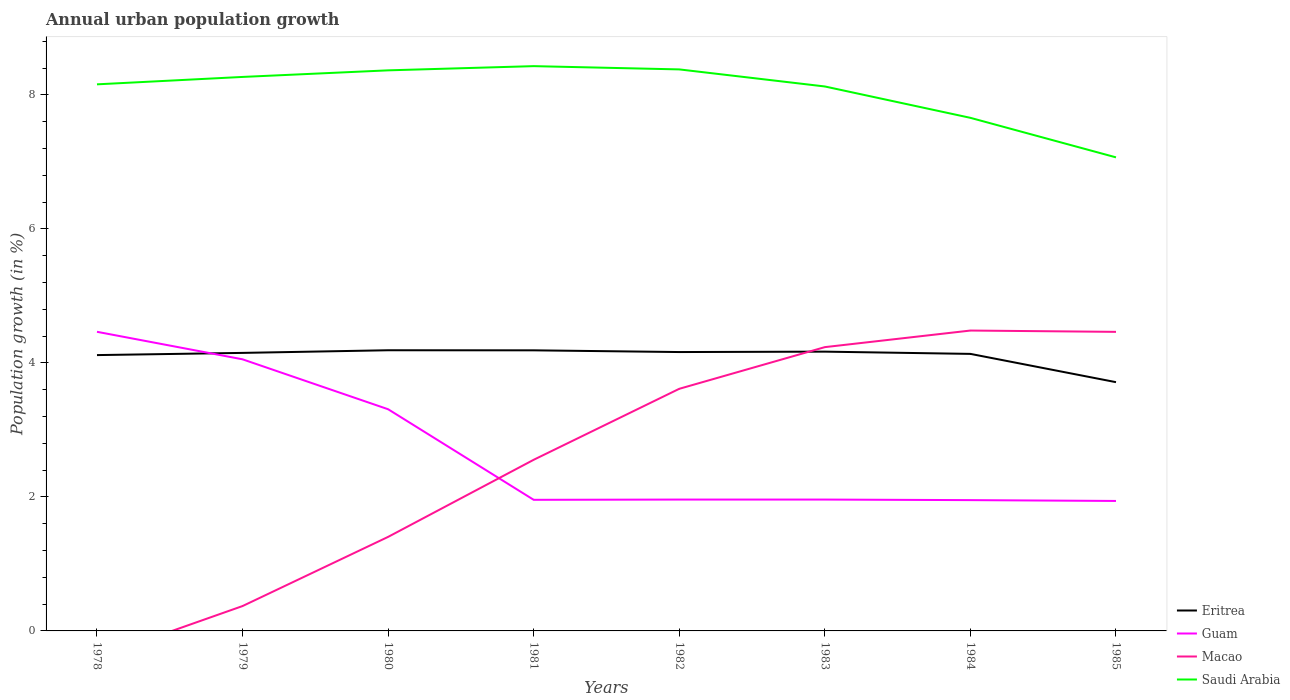Across all years, what is the maximum percentage of urban population growth in Eritrea?
Your answer should be compact. 3.71. What is the total percentage of urban population growth in Macao in the graph?
Your response must be concise. -0.87. What is the difference between the highest and the second highest percentage of urban population growth in Saudi Arabia?
Your response must be concise. 1.36. What is the difference between the highest and the lowest percentage of urban population growth in Guam?
Provide a short and direct response. 3. Is the percentage of urban population growth in Guam strictly greater than the percentage of urban population growth in Saudi Arabia over the years?
Make the answer very short. Yes. How many lines are there?
Offer a terse response. 4. How many years are there in the graph?
Ensure brevity in your answer.  8. What is the difference between two consecutive major ticks on the Y-axis?
Provide a short and direct response. 2. Does the graph contain grids?
Provide a short and direct response. No. How many legend labels are there?
Provide a succinct answer. 4. What is the title of the graph?
Provide a succinct answer. Annual urban population growth. Does "Papua New Guinea" appear as one of the legend labels in the graph?
Your response must be concise. No. What is the label or title of the Y-axis?
Offer a very short reply. Population growth (in %). What is the Population growth (in %) of Eritrea in 1978?
Your answer should be compact. 4.12. What is the Population growth (in %) of Guam in 1978?
Your answer should be very brief. 4.46. What is the Population growth (in %) of Macao in 1978?
Your answer should be very brief. 0. What is the Population growth (in %) of Saudi Arabia in 1978?
Your answer should be very brief. 8.16. What is the Population growth (in %) of Eritrea in 1979?
Provide a short and direct response. 4.15. What is the Population growth (in %) of Guam in 1979?
Provide a succinct answer. 4.05. What is the Population growth (in %) in Macao in 1979?
Ensure brevity in your answer.  0.37. What is the Population growth (in %) in Saudi Arabia in 1979?
Your response must be concise. 8.27. What is the Population growth (in %) of Eritrea in 1980?
Offer a very short reply. 4.19. What is the Population growth (in %) of Guam in 1980?
Keep it short and to the point. 3.31. What is the Population growth (in %) of Macao in 1980?
Your response must be concise. 1.4. What is the Population growth (in %) in Saudi Arabia in 1980?
Provide a short and direct response. 8.37. What is the Population growth (in %) in Eritrea in 1981?
Provide a short and direct response. 4.19. What is the Population growth (in %) in Guam in 1981?
Provide a succinct answer. 1.96. What is the Population growth (in %) of Macao in 1981?
Your answer should be compact. 2.55. What is the Population growth (in %) of Saudi Arabia in 1981?
Make the answer very short. 8.43. What is the Population growth (in %) in Eritrea in 1982?
Offer a very short reply. 4.16. What is the Population growth (in %) of Guam in 1982?
Give a very brief answer. 1.96. What is the Population growth (in %) in Macao in 1982?
Make the answer very short. 3.61. What is the Population growth (in %) in Saudi Arabia in 1982?
Provide a short and direct response. 8.38. What is the Population growth (in %) of Eritrea in 1983?
Provide a short and direct response. 4.17. What is the Population growth (in %) of Guam in 1983?
Provide a short and direct response. 1.96. What is the Population growth (in %) of Macao in 1983?
Ensure brevity in your answer.  4.24. What is the Population growth (in %) in Saudi Arabia in 1983?
Provide a short and direct response. 8.13. What is the Population growth (in %) in Eritrea in 1984?
Keep it short and to the point. 4.13. What is the Population growth (in %) in Guam in 1984?
Your answer should be compact. 1.95. What is the Population growth (in %) in Macao in 1984?
Provide a short and direct response. 4.48. What is the Population growth (in %) of Saudi Arabia in 1984?
Your response must be concise. 7.66. What is the Population growth (in %) in Eritrea in 1985?
Give a very brief answer. 3.71. What is the Population growth (in %) in Guam in 1985?
Ensure brevity in your answer.  1.94. What is the Population growth (in %) in Macao in 1985?
Provide a succinct answer. 4.46. What is the Population growth (in %) in Saudi Arabia in 1985?
Make the answer very short. 7.07. Across all years, what is the maximum Population growth (in %) in Eritrea?
Your answer should be compact. 4.19. Across all years, what is the maximum Population growth (in %) of Guam?
Your response must be concise. 4.46. Across all years, what is the maximum Population growth (in %) of Macao?
Make the answer very short. 4.48. Across all years, what is the maximum Population growth (in %) in Saudi Arabia?
Keep it short and to the point. 8.43. Across all years, what is the minimum Population growth (in %) of Eritrea?
Give a very brief answer. 3.71. Across all years, what is the minimum Population growth (in %) of Guam?
Your answer should be very brief. 1.94. Across all years, what is the minimum Population growth (in %) in Saudi Arabia?
Offer a very short reply. 7.07. What is the total Population growth (in %) of Eritrea in the graph?
Ensure brevity in your answer.  32.82. What is the total Population growth (in %) in Guam in the graph?
Provide a short and direct response. 21.6. What is the total Population growth (in %) in Macao in the graph?
Offer a very short reply. 21.12. What is the total Population growth (in %) in Saudi Arabia in the graph?
Ensure brevity in your answer.  64.45. What is the difference between the Population growth (in %) in Eritrea in 1978 and that in 1979?
Give a very brief answer. -0.03. What is the difference between the Population growth (in %) in Guam in 1978 and that in 1979?
Provide a succinct answer. 0.41. What is the difference between the Population growth (in %) in Saudi Arabia in 1978 and that in 1979?
Keep it short and to the point. -0.11. What is the difference between the Population growth (in %) in Eritrea in 1978 and that in 1980?
Give a very brief answer. -0.07. What is the difference between the Population growth (in %) of Guam in 1978 and that in 1980?
Provide a short and direct response. 1.16. What is the difference between the Population growth (in %) of Saudi Arabia in 1978 and that in 1980?
Ensure brevity in your answer.  -0.21. What is the difference between the Population growth (in %) in Eritrea in 1978 and that in 1981?
Ensure brevity in your answer.  -0.07. What is the difference between the Population growth (in %) in Guam in 1978 and that in 1981?
Provide a succinct answer. 2.51. What is the difference between the Population growth (in %) of Saudi Arabia in 1978 and that in 1981?
Ensure brevity in your answer.  -0.27. What is the difference between the Population growth (in %) in Eritrea in 1978 and that in 1982?
Provide a short and direct response. -0.05. What is the difference between the Population growth (in %) of Guam in 1978 and that in 1982?
Your response must be concise. 2.5. What is the difference between the Population growth (in %) in Saudi Arabia in 1978 and that in 1982?
Offer a very short reply. -0.22. What is the difference between the Population growth (in %) of Eritrea in 1978 and that in 1983?
Keep it short and to the point. -0.05. What is the difference between the Population growth (in %) in Guam in 1978 and that in 1983?
Provide a short and direct response. 2.5. What is the difference between the Population growth (in %) of Saudi Arabia in 1978 and that in 1983?
Your response must be concise. 0.03. What is the difference between the Population growth (in %) of Eritrea in 1978 and that in 1984?
Give a very brief answer. -0.02. What is the difference between the Population growth (in %) of Guam in 1978 and that in 1984?
Your answer should be very brief. 2.51. What is the difference between the Population growth (in %) of Saudi Arabia in 1978 and that in 1984?
Offer a very short reply. 0.5. What is the difference between the Population growth (in %) of Eritrea in 1978 and that in 1985?
Give a very brief answer. 0.4. What is the difference between the Population growth (in %) in Guam in 1978 and that in 1985?
Keep it short and to the point. 2.52. What is the difference between the Population growth (in %) in Saudi Arabia in 1978 and that in 1985?
Provide a short and direct response. 1.09. What is the difference between the Population growth (in %) in Eritrea in 1979 and that in 1980?
Provide a succinct answer. -0.04. What is the difference between the Population growth (in %) of Guam in 1979 and that in 1980?
Provide a succinct answer. 0.75. What is the difference between the Population growth (in %) in Macao in 1979 and that in 1980?
Provide a succinct answer. -1.03. What is the difference between the Population growth (in %) of Saudi Arabia in 1979 and that in 1980?
Your response must be concise. -0.1. What is the difference between the Population growth (in %) of Eritrea in 1979 and that in 1981?
Offer a very short reply. -0.04. What is the difference between the Population growth (in %) of Guam in 1979 and that in 1981?
Keep it short and to the point. 2.1. What is the difference between the Population growth (in %) in Macao in 1979 and that in 1981?
Your answer should be very brief. -2.18. What is the difference between the Population growth (in %) in Saudi Arabia in 1979 and that in 1981?
Your response must be concise. -0.16. What is the difference between the Population growth (in %) in Eritrea in 1979 and that in 1982?
Ensure brevity in your answer.  -0.01. What is the difference between the Population growth (in %) in Guam in 1979 and that in 1982?
Make the answer very short. 2.09. What is the difference between the Population growth (in %) of Macao in 1979 and that in 1982?
Provide a succinct answer. -3.24. What is the difference between the Population growth (in %) in Saudi Arabia in 1979 and that in 1982?
Offer a terse response. -0.11. What is the difference between the Population growth (in %) in Eritrea in 1979 and that in 1983?
Provide a short and direct response. -0.02. What is the difference between the Population growth (in %) of Guam in 1979 and that in 1983?
Give a very brief answer. 2.09. What is the difference between the Population growth (in %) in Macao in 1979 and that in 1983?
Ensure brevity in your answer.  -3.86. What is the difference between the Population growth (in %) of Saudi Arabia in 1979 and that in 1983?
Your answer should be very brief. 0.14. What is the difference between the Population growth (in %) of Eritrea in 1979 and that in 1984?
Make the answer very short. 0.01. What is the difference between the Population growth (in %) in Guam in 1979 and that in 1984?
Provide a succinct answer. 2.1. What is the difference between the Population growth (in %) in Macao in 1979 and that in 1984?
Your answer should be very brief. -4.11. What is the difference between the Population growth (in %) of Saudi Arabia in 1979 and that in 1984?
Your answer should be compact. 0.61. What is the difference between the Population growth (in %) of Eritrea in 1979 and that in 1985?
Ensure brevity in your answer.  0.44. What is the difference between the Population growth (in %) of Guam in 1979 and that in 1985?
Offer a terse response. 2.11. What is the difference between the Population growth (in %) in Macao in 1979 and that in 1985?
Offer a very short reply. -4.09. What is the difference between the Population growth (in %) in Saudi Arabia in 1979 and that in 1985?
Offer a very short reply. 1.2. What is the difference between the Population growth (in %) in Eritrea in 1980 and that in 1981?
Make the answer very short. 0. What is the difference between the Population growth (in %) in Guam in 1980 and that in 1981?
Your response must be concise. 1.35. What is the difference between the Population growth (in %) in Macao in 1980 and that in 1981?
Give a very brief answer. -1.15. What is the difference between the Population growth (in %) of Saudi Arabia in 1980 and that in 1981?
Ensure brevity in your answer.  -0.06. What is the difference between the Population growth (in %) in Eritrea in 1980 and that in 1982?
Ensure brevity in your answer.  0.03. What is the difference between the Population growth (in %) in Guam in 1980 and that in 1982?
Provide a succinct answer. 1.35. What is the difference between the Population growth (in %) of Macao in 1980 and that in 1982?
Provide a succinct answer. -2.21. What is the difference between the Population growth (in %) in Saudi Arabia in 1980 and that in 1982?
Make the answer very short. -0.01. What is the difference between the Population growth (in %) of Eritrea in 1980 and that in 1983?
Ensure brevity in your answer.  0.02. What is the difference between the Population growth (in %) in Guam in 1980 and that in 1983?
Make the answer very short. 1.35. What is the difference between the Population growth (in %) in Macao in 1980 and that in 1983?
Provide a short and direct response. -2.83. What is the difference between the Population growth (in %) in Saudi Arabia in 1980 and that in 1983?
Offer a terse response. 0.24. What is the difference between the Population growth (in %) of Eritrea in 1980 and that in 1984?
Make the answer very short. 0.05. What is the difference between the Population growth (in %) in Guam in 1980 and that in 1984?
Provide a short and direct response. 1.36. What is the difference between the Population growth (in %) in Macao in 1980 and that in 1984?
Ensure brevity in your answer.  -3.08. What is the difference between the Population growth (in %) in Saudi Arabia in 1980 and that in 1984?
Your answer should be very brief. 0.71. What is the difference between the Population growth (in %) of Eritrea in 1980 and that in 1985?
Ensure brevity in your answer.  0.48. What is the difference between the Population growth (in %) in Guam in 1980 and that in 1985?
Give a very brief answer. 1.37. What is the difference between the Population growth (in %) of Macao in 1980 and that in 1985?
Your answer should be very brief. -3.06. What is the difference between the Population growth (in %) in Saudi Arabia in 1980 and that in 1985?
Ensure brevity in your answer.  1.3. What is the difference between the Population growth (in %) in Eritrea in 1981 and that in 1982?
Provide a succinct answer. 0.03. What is the difference between the Population growth (in %) of Guam in 1981 and that in 1982?
Offer a terse response. -0. What is the difference between the Population growth (in %) of Macao in 1981 and that in 1982?
Your answer should be very brief. -1.06. What is the difference between the Population growth (in %) of Saudi Arabia in 1981 and that in 1982?
Give a very brief answer. 0.05. What is the difference between the Population growth (in %) in Eritrea in 1981 and that in 1983?
Your answer should be compact. 0.02. What is the difference between the Population growth (in %) of Guam in 1981 and that in 1983?
Your answer should be compact. -0. What is the difference between the Population growth (in %) in Macao in 1981 and that in 1983?
Offer a terse response. -1.68. What is the difference between the Population growth (in %) in Saudi Arabia in 1981 and that in 1983?
Offer a terse response. 0.3. What is the difference between the Population growth (in %) of Eritrea in 1981 and that in 1984?
Ensure brevity in your answer.  0.05. What is the difference between the Population growth (in %) in Guam in 1981 and that in 1984?
Keep it short and to the point. 0. What is the difference between the Population growth (in %) of Macao in 1981 and that in 1984?
Your answer should be very brief. -1.93. What is the difference between the Population growth (in %) in Saudi Arabia in 1981 and that in 1984?
Keep it short and to the point. 0.77. What is the difference between the Population growth (in %) of Eritrea in 1981 and that in 1985?
Your response must be concise. 0.48. What is the difference between the Population growth (in %) of Guam in 1981 and that in 1985?
Provide a short and direct response. 0.02. What is the difference between the Population growth (in %) in Macao in 1981 and that in 1985?
Offer a very short reply. -1.91. What is the difference between the Population growth (in %) of Saudi Arabia in 1981 and that in 1985?
Provide a short and direct response. 1.36. What is the difference between the Population growth (in %) in Eritrea in 1982 and that in 1983?
Keep it short and to the point. -0.01. What is the difference between the Population growth (in %) in Guam in 1982 and that in 1983?
Your answer should be compact. 0. What is the difference between the Population growth (in %) in Macao in 1982 and that in 1983?
Offer a terse response. -0.62. What is the difference between the Population growth (in %) of Saudi Arabia in 1982 and that in 1983?
Offer a very short reply. 0.25. What is the difference between the Population growth (in %) of Eritrea in 1982 and that in 1984?
Offer a terse response. 0.03. What is the difference between the Population growth (in %) in Guam in 1982 and that in 1984?
Keep it short and to the point. 0.01. What is the difference between the Population growth (in %) of Macao in 1982 and that in 1984?
Keep it short and to the point. -0.87. What is the difference between the Population growth (in %) in Saudi Arabia in 1982 and that in 1984?
Provide a short and direct response. 0.72. What is the difference between the Population growth (in %) of Eritrea in 1982 and that in 1985?
Make the answer very short. 0.45. What is the difference between the Population growth (in %) of Guam in 1982 and that in 1985?
Keep it short and to the point. 0.02. What is the difference between the Population growth (in %) of Macao in 1982 and that in 1985?
Provide a succinct answer. -0.85. What is the difference between the Population growth (in %) in Saudi Arabia in 1982 and that in 1985?
Provide a succinct answer. 1.31. What is the difference between the Population growth (in %) of Eritrea in 1983 and that in 1984?
Your answer should be very brief. 0.03. What is the difference between the Population growth (in %) in Guam in 1983 and that in 1984?
Your response must be concise. 0.01. What is the difference between the Population growth (in %) of Macao in 1983 and that in 1984?
Your response must be concise. -0.25. What is the difference between the Population growth (in %) in Saudi Arabia in 1983 and that in 1984?
Your response must be concise. 0.47. What is the difference between the Population growth (in %) of Eritrea in 1983 and that in 1985?
Ensure brevity in your answer.  0.46. What is the difference between the Population growth (in %) of Guam in 1983 and that in 1985?
Provide a short and direct response. 0.02. What is the difference between the Population growth (in %) of Macao in 1983 and that in 1985?
Offer a terse response. -0.23. What is the difference between the Population growth (in %) of Saudi Arabia in 1983 and that in 1985?
Make the answer very short. 1.06. What is the difference between the Population growth (in %) of Eritrea in 1984 and that in 1985?
Provide a short and direct response. 0.42. What is the difference between the Population growth (in %) of Guam in 1984 and that in 1985?
Keep it short and to the point. 0.01. What is the difference between the Population growth (in %) of Macao in 1984 and that in 1985?
Offer a terse response. 0.02. What is the difference between the Population growth (in %) in Saudi Arabia in 1984 and that in 1985?
Offer a very short reply. 0.59. What is the difference between the Population growth (in %) of Eritrea in 1978 and the Population growth (in %) of Guam in 1979?
Your answer should be very brief. 0.06. What is the difference between the Population growth (in %) in Eritrea in 1978 and the Population growth (in %) in Macao in 1979?
Keep it short and to the point. 3.75. What is the difference between the Population growth (in %) in Eritrea in 1978 and the Population growth (in %) in Saudi Arabia in 1979?
Provide a short and direct response. -4.15. What is the difference between the Population growth (in %) of Guam in 1978 and the Population growth (in %) of Macao in 1979?
Give a very brief answer. 4.09. What is the difference between the Population growth (in %) in Guam in 1978 and the Population growth (in %) in Saudi Arabia in 1979?
Make the answer very short. -3.8. What is the difference between the Population growth (in %) of Eritrea in 1978 and the Population growth (in %) of Guam in 1980?
Offer a terse response. 0.81. What is the difference between the Population growth (in %) of Eritrea in 1978 and the Population growth (in %) of Macao in 1980?
Offer a terse response. 2.71. What is the difference between the Population growth (in %) in Eritrea in 1978 and the Population growth (in %) in Saudi Arabia in 1980?
Your answer should be compact. -4.25. What is the difference between the Population growth (in %) of Guam in 1978 and the Population growth (in %) of Macao in 1980?
Give a very brief answer. 3.06. What is the difference between the Population growth (in %) of Guam in 1978 and the Population growth (in %) of Saudi Arabia in 1980?
Ensure brevity in your answer.  -3.9. What is the difference between the Population growth (in %) of Eritrea in 1978 and the Population growth (in %) of Guam in 1981?
Make the answer very short. 2.16. What is the difference between the Population growth (in %) in Eritrea in 1978 and the Population growth (in %) in Macao in 1981?
Your response must be concise. 1.56. What is the difference between the Population growth (in %) in Eritrea in 1978 and the Population growth (in %) in Saudi Arabia in 1981?
Provide a short and direct response. -4.31. What is the difference between the Population growth (in %) in Guam in 1978 and the Population growth (in %) in Macao in 1981?
Your response must be concise. 1.91. What is the difference between the Population growth (in %) of Guam in 1978 and the Population growth (in %) of Saudi Arabia in 1981?
Your answer should be compact. -3.96. What is the difference between the Population growth (in %) of Eritrea in 1978 and the Population growth (in %) of Guam in 1982?
Offer a terse response. 2.16. What is the difference between the Population growth (in %) in Eritrea in 1978 and the Population growth (in %) in Macao in 1982?
Your response must be concise. 0.5. What is the difference between the Population growth (in %) in Eritrea in 1978 and the Population growth (in %) in Saudi Arabia in 1982?
Give a very brief answer. -4.26. What is the difference between the Population growth (in %) of Guam in 1978 and the Population growth (in %) of Macao in 1982?
Your answer should be very brief. 0.85. What is the difference between the Population growth (in %) of Guam in 1978 and the Population growth (in %) of Saudi Arabia in 1982?
Make the answer very short. -3.92. What is the difference between the Population growth (in %) of Eritrea in 1978 and the Population growth (in %) of Guam in 1983?
Your answer should be very brief. 2.16. What is the difference between the Population growth (in %) in Eritrea in 1978 and the Population growth (in %) in Macao in 1983?
Offer a terse response. -0.12. What is the difference between the Population growth (in %) in Eritrea in 1978 and the Population growth (in %) in Saudi Arabia in 1983?
Your response must be concise. -4.01. What is the difference between the Population growth (in %) in Guam in 1978 and the Population growth (in %) in Macao in 1983?
Ensure brevity in your answer.  0.23. What is the difference between the Population growth (in %) of Guam in 1978 and the Population growth (in %) of Saudi Arabia in 1983?
Provide a succinct answer. -3.66. What is the difference between the Population growth (in %) in Eritrea in 1978 and the Population growth (in %) in Guam in 1984?
Your answer should be compact. 2.16. What is the difference between the Population growth (in %) in Eritrea in 1978 and the Population growth (in %) in Macao in 1984?
Ensure brevity in your answer.  -0.37. What is the difference between the Population growth (in %) of Eritrea in 1978 and the Population growth (in %) of Saudi Arabia in 1984?
Your answer should be compact. -3.54. What is the difference between the Population growth (in %) of Guam in 1978 and the Population growth (in %) of Macao in 1984?
Make the answer very short. -0.02. What is the difference between the Population growth (in %) of Guam in 1978 and the Population growth (in %) of Saudi Arabia in 1984?
Keep it short and to the point. -3.19. What is the difference between the Population growth (in %) in Eritrea in 1978 and the Population growth (in %) in Guam in 1985?
Give a very brief answer. 2.18. What is the difference between the Population growth (in %) of Eritrea in 1978 and the Population growth (in %) of Macao in 1985?
Offer a terse response. -0.35. What is the difference between the Population growth (in %) of Eritrea in 1978 and the Population growth (in %) of Saudi Arabia in 1985?
Your answer should be very brief. -2.95. What is the difference between the Population growth (in %) in Guam in 1978 and the Population growth (in %) in Macao in 1985?
Offer a very short reply. 0. What is the difference between the Population growth (in %) of Guam in 1978 and the Population growth (in %) of Saudi Arabia in 1985?
Your answer should be compact. -2.6. What is the difference between the Population growth (in %) in Eritrea in 1979 and the Population growth (in %) in Guam in 1980?
Offer a terse response. 0.84. What is the difference between the Population growth (in %) of Eritrea in 1979 and the Population growth (in %) of Macao in 1980?
Your response must be concise. 2.75. What is the difference between the Population growth (in %) in Eritrea in 1979 and the Population growth (in %) in Saudi Arabia in 1980?
Offer a very short reply. -4.22. What is the difference between the Population growth (in %) of Guam in 1979 and the Population growth (in %) of Macao in 1980?
Your answer should be very brief. 2.65. What is the difference between the Population growth (in %) of Guam in 1979 and the Population growth (in %) of Saudi Arabia in 1980?
Provide a short and direct response. -4.31. What is the difference between the Population growth (in %) of Macao in 1979 and the Population growth (in %) of Saudi Arabia in 1980?
Your answer should be compact. -8. What is the difference between the Population growth (in %) of Eritrea in 1979 and the Population growth (in %) of Guam in 1981?
Ensure brevity in your answer.  2.19. What is the difference between the Population growth (in %) in Eritrea in 1979 and the Population growth (in %) in Macao in 1981?
Your answer should be very brief. 1.6. What is the difference between the Population growth (in %) of Eritrea in 1979 and the Population growth (in %) of Saudi Arabia in 1981?
Keep it short and to the point. -4.28. What is the difference between the Population growth (in %) of Guam in 1979 and the Population growth (in %) of Macao in 1981?
Your response must be concise. 1.5. What is the difference between the Population growth (in %) in Guam in 1979 and the Population growth (in %) in Saudi Arabia in 1981?
Make the answer very short. -4.38. What is the difference between the Population growth (in %) of Macao in 1979 and the Population growth (in %) of Saudi Arabia in 1981?
Give a very brief answer. -8.06. What is the difference between the Population growth (in %) in Eritrea in 1979 and the Population growth (in %) in Guam in 1982?
Ensure brevity in your answer.  2.19. What is the difference between the Population growth (in %) in Eritrea in 1979 and the Population growth (in %) in Macao in 1982?
Provide a succinct answer. 0.54. What is the difference between the Population growth (in %) of Eritrea in 1979 and the Population growth (in %) of Saudi Arabia in 1982?
Offer a terse response. -4.23. What is the difference between the Population growth (in %) in Guam in 1979 and the Population growth (in %) in Macao in 1982?
Your answer should be compact. 0.44. What is the difference between the Population growth (in %) of Guam in 1979 and the Population growth (in %) of Saudi Arabia in 1982?
Your response must be concise. -4.33. What is the difference between the Population growth (in %) of Macao in 1979 and the Population growth (in %) of Saudi Arabia in 1982?
Ensure brevity in your answer.  -8.01. What is the difference between the Population growth (in %) of Eritrea in 1979 and the Population growth (in %) of Guam in 1983?
Your answer should be compact. 2.19. What is the difference between the Population growth (in %) in Eritrea in 1979 and the Population growth (in %) in Macao in 1983?
Make the answer very short. -0.09. What is the difference between the Population growth (in %) of Eritrea in 1979 and the Population growth (in %) of Saudi Arabia in 1983?
Ensure brevity in your answer.  -3.98. What is the difference between the Population growth (in %) of Guam in 1979 and the Population growth (in %) of Macao in 1983?
Your answer should be compact. -0.18. What is the difference between the Population growth (in %) in Guam in 1979 and the Population growth (in %) in Saudi Arabia in 1983?
Ensure brevity in your answer.  -4.07. What is the difference between the Population growth (in %) of Macao in 1979 and the Population growth (in %) of Saudi Arabia in 1983?
Keep it short and to the point. -7.75. What is the difference between the Population growth (in %) in Eritrea in 1979 and the Population growth (in %) in Guam in 1984?
Ensure brevity in your answer.  2.2. What is the difference between the Population growth (in %) in Eritrea in 1979 and the Population growth (in %) in Macao in 1984?
Your response must be concise. -0.33. What is the difference between the Population growth (in %) of Eritrea in 1979 and the Population growth (in %) of Saudi Arabia in 1984?
Keep it short and to the point. -3.51. What is the difference between the Population growth (in %) in Guam in 1979 and the Population growth (in %) in Macao in 1984?
Provide a short and direct response. -0.43. What is the difference between the Population growth (in %) in Guam in 1979 and the Population growth (in %) in Saudi Arabia in 1984?
Provide a succinct answer. -3.6. What is the difference between the Population growth (in %) in Macao in 1979 and the Population growth (in %) in Saudi Arabia in 1984?
Provide a short and direct response. -7.29. What is the difference between the Population growth (in %) in Eritrea in 1979 and the Population growth (in %) in Guam in 1985?
Offer a terse response. 2.21. What is the difference between the Population growth (in %) in Eritrea in 1979 and the Population growth (in %) in Macao in 1985?
Give a very brief answer. -0.31. What is the difference between the Population growth (in %) in Eritrea in 1979 and the Population growth (in %) in Saudi Arabia in 1985?
Offer a terse response. -2.92. What is the difference between the Population growth (in %) of Guam in 1979 and the Population growth (in %) of Macao in 1985?
Your answer should be very brief. -0.41. What is the difference between the Population growth (in %) in Guam in 1979 and the Population growth (in %) in Saudi Arabia in 1985?
Your answer should be compact. -3.01. What is the difference between the Population growth (in %) of Macao in 1979 and the Population growth (in %) of Saudi Arabia in 1985?
Keep it short and to the point. -6.7. What is the difference between the Population growth (in %) in Eritrea in 1980 and the Population growth (in %) in Guam in 1981?
Offer a very short reply. 2.23. What is the difference between the Population growth (in %) of Eritrea in 1980 and the Population growth (in %) of Macao in 1981?
Offer a very short reply. 1.63. What is the difference between the Population growth (in %) in Eritrea in 1980 and the Population growth (in %) in Saudi Arabia in 1981?
Provide a succinct answer. -4.24. What is the difference between the Population growth (in %) in Guam in 1980 and the Population growth (in %) in Macao in 1981?
Your answer should be compact. 0.75. What is the difference between the Population growth (in %) in Guam in 1980 and the Population growth (in %) in Saudi Arabia in 1981?
Make the answer very short. -5.12. What is the difference between the Population growth (in %) in Macao in 1980 and the Population growth (in %) in Saudi Arabia in 1981?
Offer a terse response. -7.03. What is the difference between the Population growth (in %) of Eritrea in 1980 and the Population growth (in %) of Guam in 1982?
Your answer should be compact. 2.23. What is the difference between the Population growth (in %) in Eritrea in 1980 and the Population growth (in %) in Macao in 1982?
Your answer should be compact. 0.58. What is the difference between the Population growth (in %) of Eritrea in 1980 and the Population growth (in %) of Saudi Arabia in 1982?
Keep it short and to the point. -4.19. What is the difference between the Population growth (in %) in Guam in 1980 and the Population growth (in %) in Macao in 1982?
Give a very brief answer. -0.3. What is the difference between the Population growth (in %) in Guam in 1980 and the Population growth (in %) in Saudi Arabia in 1982?
Your response must be concise. -5.07. What is the difference between the Population growth (in %) of Macao in 1980 and the Population growth (in %) of Saudi Arabia in 1982?
Provide a short and direct response. -6.98. What is the difference between the Population growth (in %) of Eritrea in 1980 and the Population growth (in %) of Guam in 1983?
Your answer should be very brief. 2.23. What is the difference between the Population growth (in %) in Eritrea in 1980 and the Population growth (in %) in Macao in 1983?
Provide a succinct answer. -0.05. What is the difference between the Population growth (in %) in Eritrea in 1980 and the Population growth (in %) in Saudi Arabia in 1983?
Your answer should be compact. -3.94. What is the difference between the Population growth (in %) in Guam in 1980 and the Population growth (in %) in Macao in 1983?
Make the answer very short. -0.93. What is the difference between the Population growth (in %) of Guam in 1980 and the Population growth (in %) of Saudi Arabia in 1983?
Offer a terse response. -4.82. What is the difference between the Population growth (in %) in Macao in 1980 and the Population growth (in %) in Saudi Arabia in 1983?
Make the answer very short. -6.72. What is the difference between the Population growth (in %) in Eritrea in 1980 and the Population growth (in %) in Guam in 1984?
Offer a very short reply. 2.24. What is the difference between the Population growth (in %) in Eritrea in 1980 and the Population growth (in %) in Macao in 1984?
Give a very brief answer. -0.29. What is the difference between the Population growth (in %) of Eritrea in 1980 and the Population growth (in %) of Saudi Arabia in 1984?
Offer a terse response. -3.47. What is the difference between the Population growth (in %) of Guam in 1980 and the Population growth (in %) of Macao in 1984?
Make the answer very short. -1.17. What is the difference between the Population growth (in %) of Guam in 1980 and the Population growth (in %) of Saudi Arabia in 1984?
Give a very brief answer. -4.35. What is the difference between the Population growth (in %) in Macao in 1980 and the Population growth (in %) in Saudi Arabia in 1984?
Offer a terse response. -6.25. What is the difference between the Population growth (in %) in Eritrea in 1980 and the Population growth (in %) in Guam in 1985?
Offer a very short reply. 2.25. What is the difference between the Population growth (in %) of Eritrea in 1980 and the Population growth (in %) of Macao in 1985?
Ensure brevity in your answer.  -0.27. What is the difference between the Population growth (in %) in Eritrea in 1980 and the Population growth (in %) in Saudi Arabia in 1985?
Make the answer very short. -2.88. What is the difference between the Population growth (in %) of Guam in 1980 and the Population growth (in %) of Macao in 1985?
Offer a very short reply. -1.15. What is the difference between the Population growth (in %) of Guam in 1980 and the Population growth (in %) of Saudi Arabia in 1985?
Your response must be concise. -3.76. What is the difference between the Population growth (in %) of Macao in 1980 and the Population growth (in %) of Saudi Arabia in 1985?
Offer a very short reply. -5.66. What is the difference between the Population growth (in %) of Eritrea in 1981 and the Population growth (in %) of Guam in 1982?
Your answer should be compact. 2.23. What is the difference between the Population growth (in %) in Eritrea in 1981 and the Population growth (in %) in Macao in 1982?
Offer a terse response. 0.57. What is the difference between the Population growth (in %) in Eritrea in 1981 and the Population growth (in %) in Saudi Arabia in 1982?
Keep it short and to the point. -4.19. What is the difference between the Population growth (in %) of Guam in 1981 and the Population growth (in %) of Macao in 1982?
Make the answer very short. -1.66. What is the difference between the Population growth (in %) of Guam in 1981 and the Population growth (in %) of Saudi Arabia in 1982?
Offer a very short reply. -6.42. What is the difference between the Population growth (in %) of Macao in 1981 and the Population growth (in %) of Saudi Arabia in 1982?
Your answer should be very brief. -5.83. What is the difference between the Population growth (in %) in Eritrea in 1981 and the Population growth (in %) in Guam in 1983?
Your answer should be very brief. 2.23. What is the difference between the Population growth (in %) of Eritrea in 1981 and the Population growth (in %) of Macao in 1983?
Provide a succinct answer. -0.05. What is the difference between the Population growth (in %) of Eritrea in 1981 and the Population growth (in %) of Saudi Arabia in 1983?
Make the answer very short. -3.94. What is the difference between the Population growth (in %) in Guam in 1981 and the Population growth (in %) in Macao in 1983?
Ensure brevity in your answer.  -2.28. What is the difference between the Population growth (in %) of Guam in 1981 and the Population growth (in %) of Saudi Arabia in 1983?
Keep it short and to the point. -6.17. What is the difference between the Population growth (in %) in Macao in 1981 and the Population growth (in %) in Saudi Arabia in 1983?
Your response must be concise. -5.57. What is the difference between the Population growth (in %) of Eritrea in 1981 and the Population growth (in %) of Guam in 1984?
Offer a terse response. 2.24. What is the difference between the Population growth (in %) of Eritrea in 1981 and the Population growth (in %) of Macao in 1984?
Offer a terse response. -0.3. What is the difference between the Population growth (in %) of Eritrea in 1981 and the Population growth (in %) of Saudi Arabia in 1984?
Provide a short and direct response. -3.47. What is the difference between the Population growth (in %) of Guam in 1981 and the Population growth (in %) of Macao in 1984?
Provide a short and direct response. -2.53. What is the difference between the Population growth (in %) in Guam in 1981 and the Population growth (in %) in Saudi Arabia in 1984?
Offer a very short reply. -5.7. What is the difference between the Population growth (in %) of Macao in 1981 and the Population growth (in %) of Saudi Arabia in 1984?
Offer a terse response. -5.1. What is the difference between the Population growth (in %) in Eritrea in 1981 and the Population growth (in %) in Guam in 1985?
Keep it short and to the point. 2.25. What is the difference between the Population growth (in %) in Eritrea in 1981 and the Population growth (in %) in Macao in 1985?
Give a very brief answer. -0.28. What is the difference between the Population growth (in %) in Eritrea in 1981 and the Population growth (in %) in Saudi Arabia in 1985?
Provide a short and direct response. -2.88. What is the difference between the Population growth (in %) of Guam in 1981 and the Population growth (in %) of Macao in 1985?
Give a very brief answer. -2.51. What is the difference between the Population growth (in %) in Guam in 1981 and the Population growth (in %) in Saudi Arabia in 1985?
Provide a succinct answer. -5.11. What is the difference between the Population growth (in %) of Macao in 1981 and the Population growth (in %) of Saudi Arabia in 1985?
Your answer should be compact. -4.51. What is the difference between the Population growth (in %) in Eritrea in 1982 and the Population growth (in %) in Guam in 1983?
Ensure brevity in your answer.  2.2. What is the difference between the Population growth (in %) of Eritrea in 1982 and the Population growth (in %) of Macao in 1983?
Ensure brevity in your answer.  -0.07. What is the difference between the Population growth (in %) in Eritrea in 1982 and the Population growth (in %) in Saudi Arabia in 1983?
Give a very brief answer. -3.96. What is the difference between the Population growth (in %) in Guam in 1982 and the Population growth (in %) in Macao in 1983?
Offer a very short reply. -2.27. What is the difference between the Population growth (in %) in Guam in 1982 and the Population growth (in %) in Saudi Arabia in 1983?
Offer a terse response. -6.17. What is the difference between the Population growth (in %) of Macao in 1982 and the Population growth (in %) of Saudi Arabia in 1983?
Your answer should be very brief. -4.51. What is the difference between the Population growth (in %) of Eritrea in 1982 and the Population growth (in %) of Guam in 1984?
Ensure brevity in your answer.  2.21. What is the difference between the Population growth (in %) in Eritrea in 1982 and the Population growth (in %) in Macao in 1984?
Keep it short and to the point. -0.32. What is the difference between the Population growth (in %) in Eritrea in 1982 and the Population growth (in %) in Saudi Arabia in 1984?
Provide a short and direct response. -3.5. What is the difference between the Population growth (in %) in Guam in 1982 and the Population growth (in %) in Macao in 1984?
Ensure brevity in your answer.  -2.52. What is the difference between the Population growth (in %) of Guam in 1982 and the Population growth (in %) of Saudi Arabia in 1984?
Give a very brief answer. -5.7. What is the difference between the Population growth (in %) in Macao in 1982 and the Population growth (in %) in Saudi Arabia in 1984?
Ensure brevity in your answer.  -4.04. What is the difference between the Population growth (in %) in Eritrea in 1982 and the Population growth (in %) in Guam in 1985?
Make the answer very short. 2.22. What is the difference between the Population growth (in %) of Eritrea in 1982 and the Population growth (in %) of Macao in 1985?
Your response must be concise. -0.3. What is the difference between the Population growth (in %) of Eritrea in 1982 and the Population growth (in %) of Saudi Arabia in 1985?
Your answer should be compact. -2.91. What is the difference between the Population growth (in %) in Guam in 1982 and the Population growth (in %) in Macao in 1985?
Keep it short and to the point. -2.5. What is the difference between the Population growth (in %) of Guam in 1982 and the Population growth (in %) of Saudi Arabia in 1985?
Offer a terse response. -5.11. What is the difference between the Population growth (in %) of Macao in 1982 and the Population growth (in %) of Saudi Arabia in 1985?
Provide a short and direct response. -3.45. What is the difference between the Population growth (in %) of Eritrea in 1983 and the Population growth (in %) of Guam in 1984?
Ensure brevity in your answer.  2.22. What is the difference between the Population growth (in %) of Eritrea in 1983 and the Population growth (in %) of Macao in 1984?
Ensure brevity in your answer.  -0.31. What is the difference between the Population growth (in %) of Eritrea in 1983 and the Population growth (in %) of Saudi Arabia in 1984?
Make the answer very short. -3.49. What is the difference between the Population growth (in %) in Guam in 1983 and the Population growth (in %) in Macao in 1984?
Offer a very short reply. -2.52. What is the difference between the Population growth (in %) in Guam in 1983 and the Population growth (in %) in Saudi Arabia in 1984?
Provide a short and direct response. -5.7. What is the difference between the Population growth (in %) of Macao in 1983 and the Population growth (in %) of Saudi Arabia in 1984?
Provide a short and direct response. -3.42. What is the difference between the Population growth (in %) in Eritrea in 1983 and the Population growth (in %) in Guam in 1985?
Offer a terse response. 2.23. What is the difference between the Population growth (in %) of Eritrea in 1983 and the Population growth (in %) of Macao in 1985?
Your response must be concise. -0.3. What is the difference between the Population growth (in %) in Eritrea in 1983 and the Population growth (in %) in Saudi Arabia in 1985?
Give a very brief answer. -2.9. What is the difference between the Population growth (in %) in Guam in 1983 and the Population growth (in %) in Macao in 1985?
Offer a very short reply. -2.5. What is the difference between the Population growth (in %) in Guam in 1983 and the Population growth (in %) in Saudi Arabia in 1985?
Your answer should be very brief. -5.11. What is the difference between the Population growth (in %) in Macao in 1983 and the Population growth (in %) in Saudi Arabia in 1985?
Your response must be concise. -2.83. What is the difference between the Population growth (in %) of Eritrea in 1984 and the Population growth (in %) of Guam in 1985?
Keep it short and to the point. 2.19. What is the difference between the Population growth (in %) of Eritrea in 1984 and the Population growth (in %) of Macao in 1985?
Offer a terse response. -0.33. What is the difference between the Population growth (in %) of Eritrea in 1984 and the Population growth (in %) of Saudi Arabia in 1985?
Provide a short and direct response. -2.93. What is the difference between the Population growth (in %) in Guam in 1984 and the Population growth (in %) in Macao in 1985?
Make the answer very short. -2.51. What is the difference between the Population growth (in %) in Guam in 1984 and the Population growth (in %) in Saudi Arabia in 1985?
Make the answer very short. -5.12. What is the difference between the Population growth (in %) in Macao in 1984 and the Population growth (in %) in Saudi Arabia in 1985?
Your answer should be compact. -2.58. What is the average Population growth (in %) of Eritrea per year?
Ensure brevity in your answer.  4.1. What is the average Population growth (in %) in Guam per year?
Provide a short and direct response. 2.7. What is the average Population growth (in %) in Macao per year?
Your answer should be compact. 2.64. What is the average Population growth (in %) in Saudi Arabia per year?
Give a very brief answer. 8.06. In the year 1978, what is the difference between the Population growth (in %) in Eritrea and Population growth (in %) in Guam?
Give a very brief answer. -0.35. In the year 1978, what is the difference between the Population growth (in %) of Eritrea and Population growth (in %) of Saudi Arabia?
Offer a very short reply. -4.04. In the year 1978, what is the difference between the Population growth (in %) in Guam and Population growth (in %) in Saudi Arabia?
Your response must be concise. -3.69. In the year 1979, what is the difference between the Population growth (in %) in Eritrea and Population growth (in %) in Guam?
Your answer should be very brief. 0.1. In the year 1979, what is the difference between the Population growth (in %) of Eritrea and Population growth (in %) of Macao?
Offer a terse response. 3.78. In the year 1979, what is the difference between the Population growth (in %) of Eritrea and Population growth (in %) of Saudi Arabia?
Your answer should be compact. -4.12. In the year 1979, what is the difference between the Population growth (in %) in Guam and Population growth (in %) in Macao?
Provide a succinct answer. 3.68. In the year 1979, what is the difference between the Population growth (in %) in Guam and Population growth (in %) in Saudi Arabia?
Provide a short and direct response. -4.21. In the year 1979, what is the difference between the Population growth (in %) of Macao and Population growth (in %) of Saudi Arabia?
Your answer should be compact. -7.9. In the year 1980, what is the difference between the Population growth (in %) in Eritrea and Population growth (in %) in Guam?
Your response must be concise. 0.88. In the year 1980, what is the difference between the Population growth (in %) in Eritrea and Population growth (in %) in Macao?
Your answer should be compact. 2.79. In the year 1980, what is the difference between the Population growth (in %) in Eritrea and Population growth (in %) in Saudi Arabia?
Make the answer very short. -4.18. In the year 1980, what is the difference between the Population growth (in %) in Guam and Population growth (in %) in Macao?
Offer a very short reply. 1.9. In the year 1980, what is the difference between the Population growth (in %) of Guam and Population growth (in %) of Saudi Arabia?
Offer a terse response. -5.06. In the year 1980, what is the difference between the Population growth (in %) of Macao and Population growth (in %) of Saudi Arabia?
Your response must be concise. -6.96. In the year 1981, what is the difference between the Population growth (in %) in Eritrea and Population growth (in %) in Guam?
Your answer should be compact. 2.23. In the year 1981, what is the difference between the Population growth (in %) in Eritrea and Population growth (in %) in Macao?
Your response must be concise. 1.63. In the year 1981, what is the difference between the Population growth (in %) of Eritrea and Population growth (in %) of Saudi Arabia?
Offer a terse response. -4.24. In the year 1981, what is the difference between the Population growth (in %) in Guam and Population growth (in %) in Macao?
Provide a succinct answer. -0.6. In the year 1981, what is the difference between the Population growth (in %) in Guam and Population growth (in %) in Saudi Arabia?
Offer a very short reply. -6.47. In the year 1981, what is the difference between the Population growth (in %) in Macao and Population growth (in %) in Saudi Arabia?
Your answer should be very brief. -5.87. In the year 1982, what is the difference between the Population growth (in %) of Eritrea and Population growth (in %) of Guam?
Ensure brevity in your answer.  2.2. In the year 1982, what is the difference between the Population growth (in %) of Eritrea and Population growth (in %) of Macao?
Make the answer very short. 0.55. In the year 1982, what is the difference between the Population growth (in %) in Eritrea and Population growth (in %) in Saudi Arabia?
Your answer should be very brief. -4.22. In the year 1982, what is the difference between the Population growth (in %) in Guam and Population growth (in %) in Macao?
Your response must be concise. -1.65. In the year 1982, what is the difference between the Population growth (in %) in Guam and Population growth (in %) in Saudi Arabia?
Your response must be concise. -6.42. In the year 1982, what is the difference between the Population growth (in %) in Macao and Population growth (in %) in Saudi Arabia?
Your answer should be very brief. -4.77. In the year 1983, what is the difference between the Population growth (in %) in Eritrea and Population growth (in %) in Guam?
Make the answer very short. 2.21. In the year 1983, what is the difference between the Population growth (in %) of Eritrea and Population growth (in %) of Macao?
Offer a terse response. -0.07. In the year 1983, what is the difference between the Population growth (in %) of Eritrea and Population growth (in %) of Saudi Arabia?
Keep it short and to the point. -3.96. In the year 1983, what is the difference between the Population growth (in %) in Guam and Population growth (in %) in Macao?
Provide a succinct answer. -2.27. In the year 1983, what is the difference between the Population growth (in %) in Guam and Population growth (in %) in Saudi Arabia?
Provide a succinct answer. -6.17. In the year 1983, what is the difference between the Population growth (in %) in Macao and Population growth (in %) in Saudi Arabia?
Provide a short and direct response. -3.89. In the year 1984, what is the difference between the Population growth (in %) of Eritrea and Population growth (in %) of Guam?
Your answer should be compact. 2.18. In the year 1984, what is the difference between the Population growth (in %) of Eritrea and Population growth (in %) of Macao?
Provide a succinct answer. -0.35. In the year 1984, what is the difference between the Population growth (in %) of Eritrea and Population growth (in %) of Saudi Arabia?
Your answer should be very brief. -3.52. In the year 1984, what is the difference between the Population growth (in %) in Guam and Population growth (in %) in Macao?
Offer a terse response. -2.53. In the year 1984, what is the difference between the Population growth (in %) of Guam and Population growth (in %) of Saudi Arabia?
Your answer should be compact. -5.71. In the year 1984, what is the difference between the Population growth (in %) of Macao and Population growth (in %) of Saudi Arabia?
Provide a succinct answer. -3.17. In the year 1985, what is the difference between the Population growth (in %) in Eritrea and Population growth (in %) in Guam?
Make the answer very short. 1.77. In the year 1985, what is the difference between the Population growth (in %) of Eritrea and Population growth (in %) of Macao?
Offer a very short reply. -0.75. In the year 1985, what is the difference between the Population growth (in %) in Eritrea and Population growth (in %) in Saudi Arabia?
Your answer should be compact. -3.36. In the year 1985, what is the difference between the Population growth (in %) in Guam and Population growth (in %) in Macao?
Offer a terse response. -2.52. In the year 1985, what is the difference between the Population growth (in %) in Guam and Population growth (in %) in Saudi Arabia?
Your answer should be compact. -5.13. In the year 1985, what is the difference between the Population growth (in %) of Macao and Population growth (in %) of Saudi Arabia?
Provide a short and direct response. -2.6. What is the ratio of the Population growth (in %) in Eritrea in 1978 to that in 1979?
Make the answer very short. 0.99. What is the ratio of the Population growth (in %) of Guam in 1978 to that in 1979?
Give a very brief answer. 1.1. What is the ratio of the Population growth (in %) of Saudi Arabia in 1978 to that in 1979?
Your answer should be very brief. 0.99. What is the ratio of the Population growth (in %) of Eritrea in 1978 to that in 1980?
Offer a very short reply. 0.98. What is the ratio of the Population growth (in %) of Guam in 1978 to that in 1980?
Ensure brevity in your answer.  1.35. What is the ratio of the Population growth (in %) of Eritrea in 1978 to that in 1981?
Ensure brevity in your answer.  0.98. What is the ratio of the Population growth (in %) in Guam in 1978 to that in 1981?
Your response must be concise. 2.28. What is the ratio of the Population growth (in %) of Saudi Arabia in 1978 to that in 1981?
Give a very brief answer. 0.97. What is the ratio of the Population growth (in %) of Eritrea in 1978 to that in 1982?
Your response must be concise. 0.99. What is the ratio of the Population growth (in %) of Guam in 1978 to that in 1982?
Ensure brevity in your answer.  2.28. What is the ratio of the Population growth (in %) in Saudi Arabia in 1978 to that in 1982?
Offer a terse response. 0.97. What is the ratio of the Population growth (in %) in Eritrea in 1978 to that in 1983?
Provide a succinct answer. 0.99. What is the ratio of the Population growth (in %) in Guam in 1978 to that in 1983?
Ensure brevity in your answer.  2.28. What is the ratio of the Population growth (in %) of Saudi Arabia in 1978 to that in 1983?
Provide a short and direct response. 1. What is the ratio of the Population growth (in %) of Eritrea in 1978 to that in 1984?
Your answer should be compact. 1. What is the ratio of the Population growth (in %) in Guam in 1978 to that in 1984?
Your answer should be compact. 2.29. What is the ratio of the Population growth (in %) in Saudi Arabia in 1978 to that in 1984?
Keep it short and to the point. 1.07. What is the ratio of the Population growth (in %) in Eritrea in 1978 to that in 1985?
Your response must be concise. 1.11. What is the ratio of the Population growth (in %) in Guam in 1978 to that in 1985?
Give a very brief answer. 2.3. What is the ratio of the Population growth (in %) of Saudi Arabia in 1978 to that in 1985?
Offer a terse response. 1.15. What is the ratio of the Population growth (in %) of Eritrea in 1979 to that in 1980?
Provide a short and direct response. 0.99. What is the ratio of the Population growth (in %) of Guam in 1979 to that in 1980?
Your response must be concise. 1.23. What is the ratio of the Population growth (in %) of Macao in 1979 to that in 1980?
Ensure brevity in your answer.  0.26. What is the ratio of the Population growth (in %) in Saudi Arabia in 1979 to that in 1980?
Your response must be concise. 0.99. What is the ratio of the Population growth (in %) of Eritrea in 1979 to that in 1981?
Make the answer very short. 0.99. What is the ratio of the Population growth (in %) in Guam in 1979 to that in 1981?
Ensure brevity in your answer.  2.07. What is the ratio of the Population growth (in %) in Macao in 1979 to that in 1981?
Make the answer very short. 0.15. What is the ratio of the Population growth (in %) in Saudi Arabia in 1979 to that in 1981?
Give a very brief answer. 0.98. What is the ratio of the Population growth (in %) in Eritrea in 1979 to that in 1982?
Your response must be concise. 1. What is the ratio of the Population growth (in %) of Guam in 1979 to that in 1982?
Offer a terse response. 2.07. What is the ratio of the Population growth (in %) of Macao in 1979 to that in 1982?
Keep it short and to the point. 0.1. What is the ratio of the Population growth (in %) in Saudi Arabia in 1979 to that in 1982?
Provide a succinct answer. 0.99. What is the ratio of the Population growth (in %) in Eritrea in 1979 to that in 1983?
Ensure brevity in your answer.  1. What is the ratio of the Population growth (in %) of Guam in 1979 to that in 1983?
Make the answer very short. 2.07. What is the ratio of the Population growth (in %) in Macao in 1979 to that in 1983?
Provide a short and direct response. 0.09. What is the ratio of the Population growth (in %) of Saudi Arabia in 1979 to that in 1983?
Offer a terse response. 1.02. What is the ratio of the Population growth (in %) in Guam in 1979 to that in 1984?
Your answer should be very brief. 2.08. What is the ratio of the Population growth (in %) of Macao in 1979 to that in 1984?
Ensure brevity in your answer.  0.08. What is the ratio of the Population growth (in %) in Saudi Arabia in 1979 to that in 1984?
Offer a terse response. 1.08. What is the ratio of the Population growth (in %) of Eritrea in 1979 to that in 1985?
Provide a short and direct response. 1.12. What is the ratio of the Population growth (in %) in Guam in 1979 to that in 1985?
Offer a very short reply. 2.09. What is the ratio of the Population growth (in %) in Macao in 1979 to that in 1985?
Ensure brevity in your answer.  0.08. What is the ratio of the Population growth (in %) of Saudi Arabia in 1979 to that in 1985?
Offer a very short reply. 1.17. What is the ratio of the Population growth (in %) in Guam in 1980 to that in 1981?
Give a very brief answer. 1.69. What is the ratio of the Population growth (in %) of Macao in 1980 to that in 1981?
Your answer should be very brief. 0.55. What is the ratio of the Population growth (in %) in Saudi Arabia in 1980 to that in 1981?
Provide a short and direct response. 0.99. What is the ratio of the Population growth (in %) in Eritrea in 1980 to that in 1982?
Your answer should be very brief. 1.01. What is the ratio of the Population growth (in %) of Guam in 1980 to that in 1982?
Provide a short and direct response. 1.69. What is the ratio of the Population growth (in %) of Macao in 1980 to that in 1982?
Keep it short and to the point. 0.39. What is the ratio of the Population growth (in %) in Guam in 1980 to that in 1983?
Offer a terse response. 1.69. What is the ratio of the Population growth (in %) in Macao in 1980 to that in 1983?
Ensure brevity in your answer.  0.33. What is the ratio of the Population growth (in %) in Saudi Arabia in 1980 to that in 1983?
Offer a very short reply. 1.03. What is the ratio of the Population growth (in %) of Eritrea in 1980 to that in 1984?
Your answer should be very brief. 1.01. What is the ratio of the Population growth (in %) of Guam in 1980 to that in 1984?
Your answer should be compact. 1.69. What is the ratio of the Population growth (in %) in Macao in 1980 to that in 1984?
Your answer should be very brief. 0.31. What is the ratio of the Population growth (in %) in Saudi Arabia in 1980 to that in 1984?
Ensure brevity in your answer.  1.09. What is the ratio of the Population growth (in %) in Eritrea in 1980 to that in 1985?
Your answer should be compact. 1.13. What is the ratio of the Population growth (in %) of Guam in 1980 to that in 1985?
Provide a short and direct response. 1.71. What is the ratio of the Population growth (in %) in Macao in 1980 to that in 1985?
Your answer should be very brief. 0.31. What is the ratio of the Population growth (in %) in Saudi Arabia in 1980 to that in 1985?
Provide a succinct answer. 1.18. What is the ratio of the Population growth (in %) of Eritrea in 1981 to that in 1982?
Your answer should be very brief. 1.01. What is the ratio of the Population growth (in %) in Macao in 1981 to that in 1982?
Keep it short and to the point. 0.71. What is the ratio of the Population growth (in %) of Macao in 1981 to that in 1983?
Your response must be concise. 0.6. What is the ratio of the Population growth (in %) in Saudi Arabia in 1981 to that in 1983?
Your answer should be compact. 1.04. What is the ratio of the Population growth (in %) in Eritrea in 1981 to that in 1984?
Keep it short and to the point. 1.01. What is the ratio of the Population growth (in %) in Guam in 1981 to that in 1984?
Provide a succinct answer. 1. What is the ratio of the Population growth (in %) in Macao in 1981 to that in 1984?
Provide a short and direct response. 0.57. What is the ratio of the Population growth (in %) in Saudi Arabia in 1981 to that in 1984?
Your response must be concise. 1.1. What is the ratio of the Population growth (in %) of Eritrea in 1981 to that in 1985?
Your response must be concise. 1.13. What is the ratio of the Population growth (in %) of Guam in 1981 to that in 1985?
Provide a succinct answer. 1.01. What is the ratio of the Population growth (in %) of Macao in 1981 to that in 1985?
Offer a terse response. 0.57. What is the ratio of the Population growth (in %) in Saudi Arabia in 1981 to that in 1985?
Your answer should be very brief. 1.19. What is the ratio of the Population growth (in %) in Eritrea in 1982 to that in 1983?
Provide a succinct answer. 1. What is the ratio of the Population growth (in %) in Guam in 1982 to that in 1983?
Make the answer very short. 1. What is the ratio of the Population growth (in %) in Macao in 1982 to that in 1983?
Your response must be concise. 0.85. What is the ratio of the Population growth (in %) in Saudi Arabia in 1982 to that in 1983?
Your answer should be very brief. 1.03. What is the ratio of the Population growth (in %) in Eritrea in 1982 to that in 1984?
Provide a succinct answer. 1.01. What is the ratio of the Population growth (in %) in Guam in 1982 to that in 1984?
Ensure brevity in your answer.  1. What is the ratio of the Population growth (in %) in Macao in 1982 to that in 1984?
Give a very brief answer. 0.81. What is the ratio of the Population growth (in %) of Saudi Arabia in 1982 to that in 1984?
Give a very brief answer. 1.09. What is the ratio of the Population growth (in %) of Eritrea in 1982 to that in 1985?
Your response must be concise. 1.12. What is the ratio of the Population growth (in %) of Guam in 1982 to that in 1985?
Make the answer very short. 1.01. What is the ratio of the Population growth (in %) in Macao in 1982 to that in 1985?
Offer a very short reply. 0.81. What is the ratio of the Population growth (in %) in Saudi Arabia in 1982 to that in 1985?
Your answer should be very brief. 1.19. What is the ratio of the Population growth (in %) of Eritrea in 1983 to that in 1984?
Ensure brevity in your answer.  1.01. What is the ratio of the Population growth (in %) in Macao in 1983 to that in 1984?
Keep it short and to the point. 0.94. What is the ratio of the Population growth (in %) of Saudi Arabia in 1983 to that in 1984?
Offer a terse response. 1.06. What is the ratio of the Population growth (in %) in Eritrea in 1983 to that in 1985?
Ensure brevity in your answer.  1.12. What is the ratio of the Population growth (in %) in Guam in 1983 to that in 1985?
Keep it short and to the point. 1.01. What is the ratio of the Population growth (in %) of Macao in 1983 to that in 1985?
Make the answer very short. 0.95. What is the ratio of the Population growth (in %) of Saudi Arabia in 1983 to that in 1985?
Keep it short and to the point. 1.15. What is the ratio of the Population growth (in %) of Eritrea in 1984 to that in 1985?
Provide a succinct answer. 1.11. What is the ratio of the Population growth (in %) of Macao in 1984 to that in 1985?
Offer a very short reply. 1. What is the ratio of the Population growth (in %) in Saudi Arabia in 1984 to that in 1985?
Your response must be concise. 1.08. What is the difference between the highest and the second highest Population growth (in %) in Eritrea?
Offer a very short reply. 0. What is the difference between the highest and the second highest Population growth (in %) of Guam?
Your answer should be very brief. 0.41. What is the difference between the highest and the second highest Population growth (in %) in Macao?
Your response must be concise. 0.02. What is the difference between the highest and the second highest Population growth (in %) in Saudi Arabia?
Your answer should be compact. 0.05. What is the difference between the highest and the lowest Population growth (in %) in Eritrea?
Make the answer very short. 0.48. What is the difference between the highest and the lowest Population growth (in %) in Guam?
Your response must be concise. 2.52. What is the difference between the highest and the lowest Population growth (in %) in Macao?
Offer a terse response. 4.48. What is the difference between the highest and the lowest Population growth (in %) of Saudi Arabia?
Make the answer very short. 1.36. 